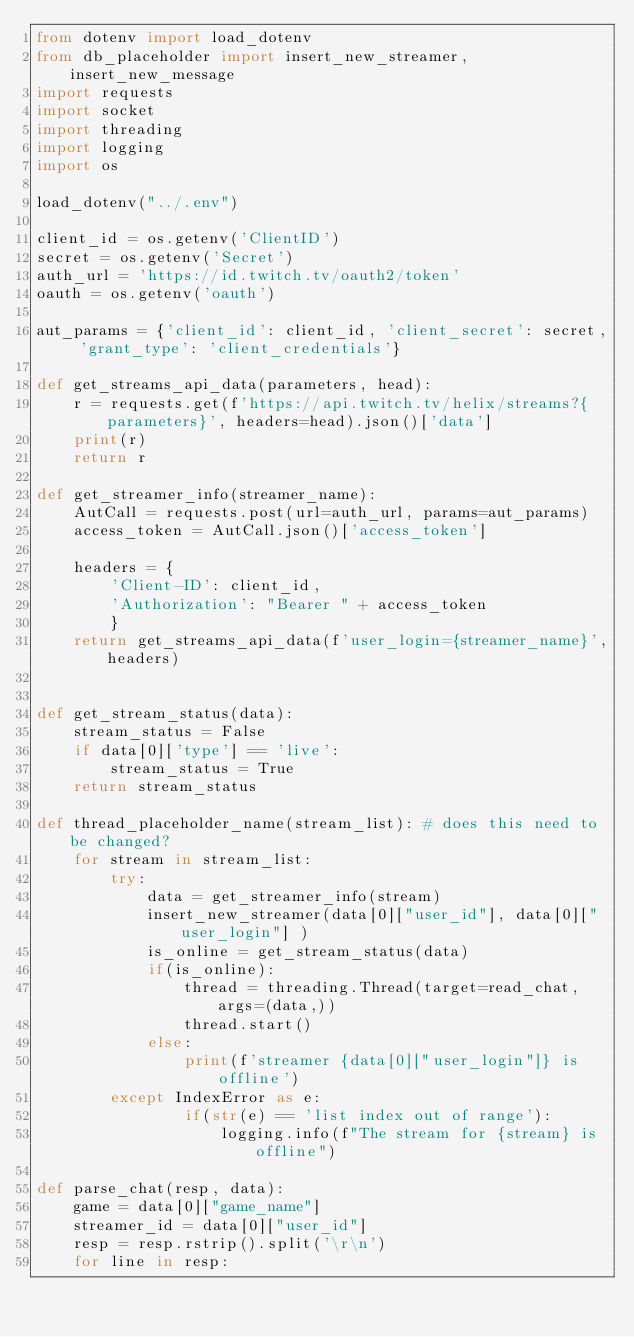<code> <loc_0><loc_0><loc_500><loc_500><_Python_>from dotenv import load_dotenv
from db_placeholder import insert_new_streamer, insert_new_message
import requests
import socket
import threading
import logging
import os

load_dotenv("../.env")

client_id = os.getenv('ClientID')
secret = os.getenv('Secret')
auth_url = 'https://id.twitch.tv/oauth2/token'
oauth = os.getenv('oauth')

aut_params = {'client_id': client_id, 'client_secret': secret, 'grant_type': 'client_credentials'}

def get_streams_api_data(parameters, head):
    r = requests.get(f'https://api.twitch.tv/helix/streams?{parameters}', headers=head).json()['data']
    print(r)
    return r

def get_streamer_info(streamer_name):
    AutCall = requests.post(url=auth_url, params=aut_params) 
    access_token = AutCall.json()['access_token']

    headers = {
        'Client-ID': client_id,
        'Authorization': "Bearer " + access_token
        }
    return get_streams_api_data(f'user_login={streamer_name}',headers)
    

def get_stream_status(data):
    stream_status = False
    if data[0]['type'] == 'live':
        stream_status = True
    return stream_status

def thread_placeholder_name(stream_list): # does this need to be changed?
    for stream in stream_list:
        try:
            data = get_streamer_info(stream)
            insert_new_streamer(data[0]["user_id"], data[0]["user_login"] )
            is_online = get_stream_status(data)
            if(is_online):
                thread = threading.Thread(target=read_chat, args=(data,))
                thread.start()
            else:
                print(f'streamer {data[0]["user_login"]} is offline')
        except IndexError as e:
                if(str(e) == 'list index out of range'):
                    logging.info(f"The stream for {stream} is offline")

def parse_chat(resp, data):
    game = data[0]["game_name"]
    streamer_id = data[0]["user_id"]
    resp = resp.rstrip().split('\r\n')
    for line in resp:</code> 